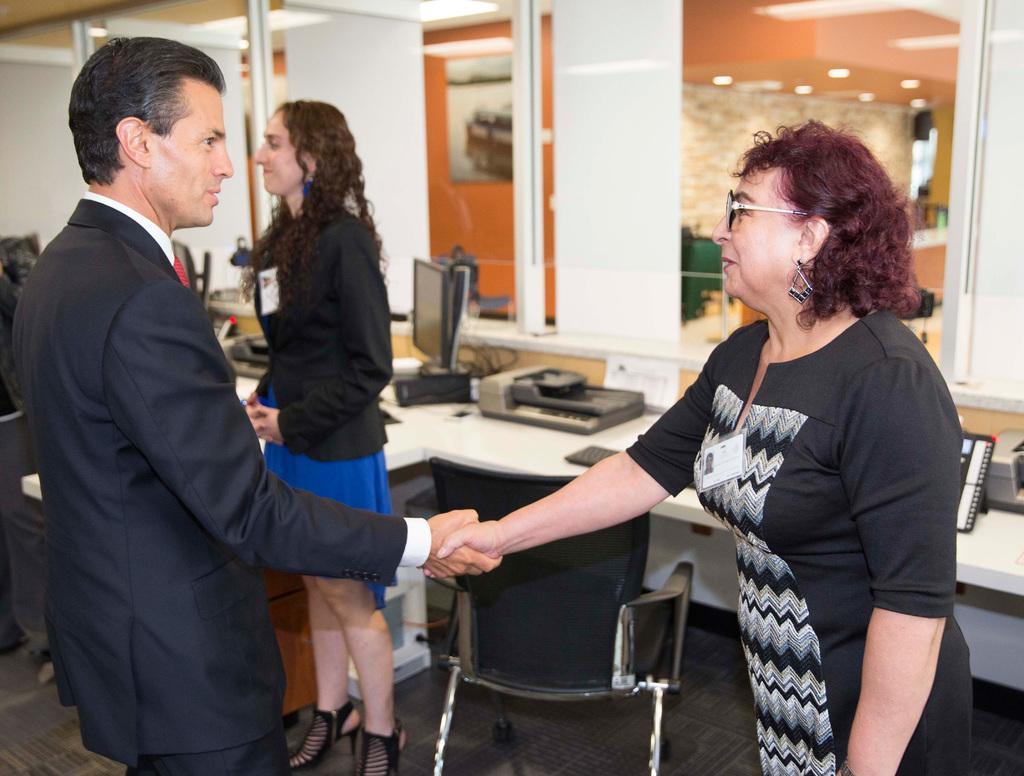In one or two sentences, can you explain what this image depicts? In this picture we can see a man and two women, beside them we can see a chair, a monitor, machines and other things on the table, in the background we can see few lights. 